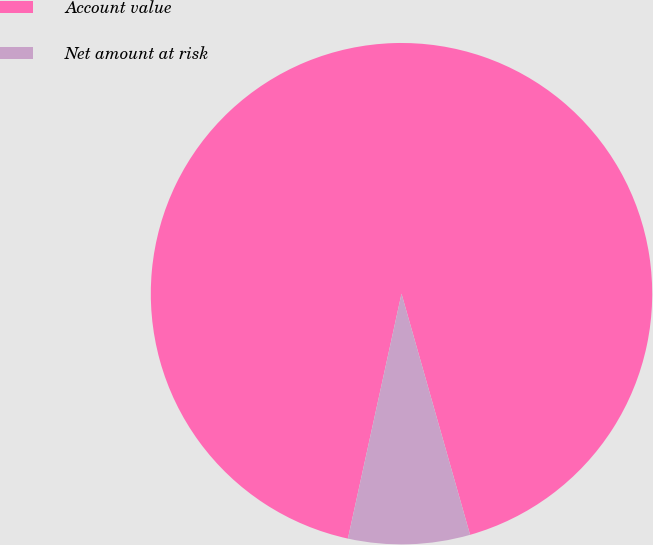Convert chart to OTSL. <chart><loc_0><loc_0><loc_500><loc_500><pie_chart><fcel>Account value<fcel>Net amount at risk<nl><fcel>92.16%<fcel>7.84%<nl></chart> 